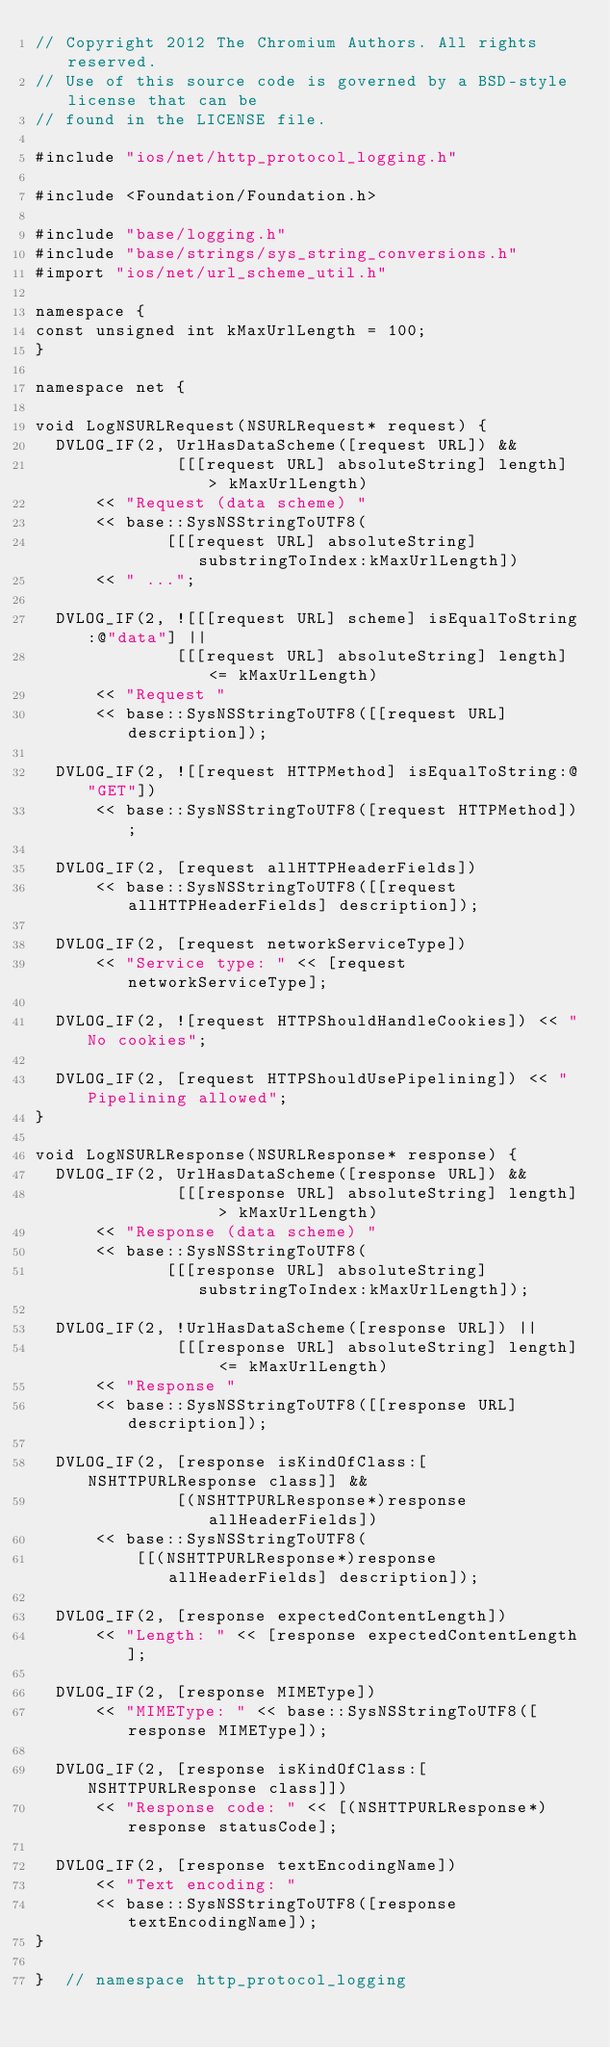<code> <loc_0><loc_0><loc_500><loc_500><_ObjectiveC_>// Copyright 2012 The Chromium Authors. All rights reserved.
// Use of this source code is governed by a BSD-style license that can be
// found in the LICENSE file.

#include "ios/net/http_protocol_logging.h"

#include <Foundation/Foundation.h>

#include "base/logging.h"
#include "base/strings/sys_string_conversions.h"
#import "ios/net/url_scheme_util.h"

namespace {
const unsigned int kMaxUrlLength = 100;
}

namespace net {

void LogNSURLRequest(NSURLRequest* request) {
  DVLOG_IF(2, UrlHasDataScheme([request URL]) &&
              [[[request URL] absoluteString] length] > kMaxUrlLength)
      << "Request (data scheme) "
      << base::SysNSStringToUTF8(
             [[[request URL] absoluteString] substringToIndex:kMaxUrlLength])
      << " ...";

  DVLOG_IF(2, ![[[request URL] scheme] isEqualToString:@"data"] ||
              [[[request URL] absoluteString] length] <= kMaxUrlLength)
      << "Request "
      << base::SysNSStringToUTF8([[request URL] description]);

  DVLOG_IF(2, ![[request HTTPMethod] isEqualToString:@"GET"])
      << base::SysNSStringToUTF8([request HTTPMethod]);

  DVLOG_IF(2, [request allHTTPHeaderFields])
      << base::SysNSStringToUTF8([[request allHTTPHeaderFields] description]);

  DVLOG_IF(2, [request networkServiceType])
      << "Service type: " << [request networkServiceType];

  DVLOG_IF(2, ![request HTTPShouldHandleCookies]) << "No cookies";

  DVLOG_IF(2, [request HTTPShouldUsePipelining]) << "Pipelining allowed";
}

void LogNSURLResponse(NSURLResponse* response) {
  DVLOG_IF(2, UrlHasDataScheme([response URL]) &&
              [[[response URL] absoluteString] length] > kMaxUrlLength)
      << "Response (data scheme) "
      << base::SysNSStringToUTF8(
             [[[response URL] absoluteString] substringToIndex:kMaxUrlLength]);

  DVLOG_IF(2, !UrlHasDataScheme([response URL]) ||
              [[[response URL] absoluteString] length] <= kMaxUrlLength)
      << "Response "
      << base::SysNSStringToUTF8([[response URL] description]);

  DVLOG_IF(2, [response isKindOfClass:[NSHTTPURLResponse class]] &&
              [(NSHTTPURLResponse*)response allHeaderFields])
      << base::SysNSStringToUTF8(
          [[(NSHTTPURLResponse*)response allHeaderFields] description]);

  DVLOG_IF(2, [response expectedContentLength])
      << "Length: " << [response expectedContentLength];

  DVLOG_IF(2, [response MIMEType])
      << "MIMEType: " << base::SysNSStringToUTF8([response MIMEType]);

  DVLOG_IF(2, [response isKindOfClass:[NSHTTPURLResponse class]])
      << "Response code: " << [(NSHTTPURLResponse*)response statusCode];

  DVLOG_IF(2, [response textEncodingName])
      << "Text encoding: "
      << base::SysNSStringToUTF8([response textEncodingName]);
}

}  // namespace http_protocol_logging
</code> 